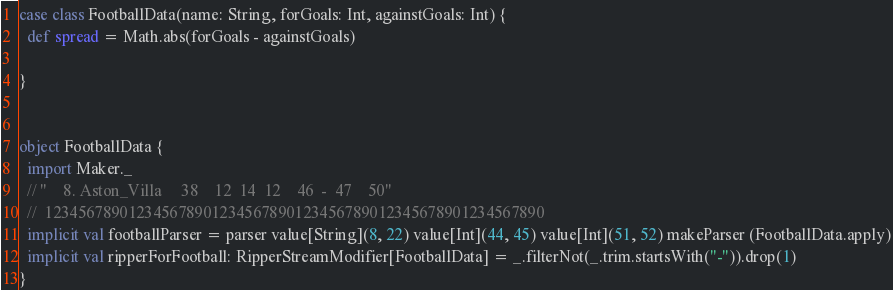Convert code to text. <code><loc_0><loc_0><loc_500><loc_500><_Scala_>case class FootballData(name: String, forGoals: Int, againstGoals: Int) {
  def spread = Math.abs(forGoals - againstGoals)

}


object FootballData {
  import Maker._
  // "    8. Aston_Villa     38    12  14  12    46  -  47    50"
  //  123456789012345678901234567890123456789012345678901234567890
  implicit val footballParser = parser value[String](8, 22) value[Int](44, 45) value[Int](51, 52) makeParser (FootballData.apply)
  implicit val ripperForFootball: RipperStreamModifier[FootballData] = _.filterNot(_.trim.startsWith("-")).drop(1)
}</code> 